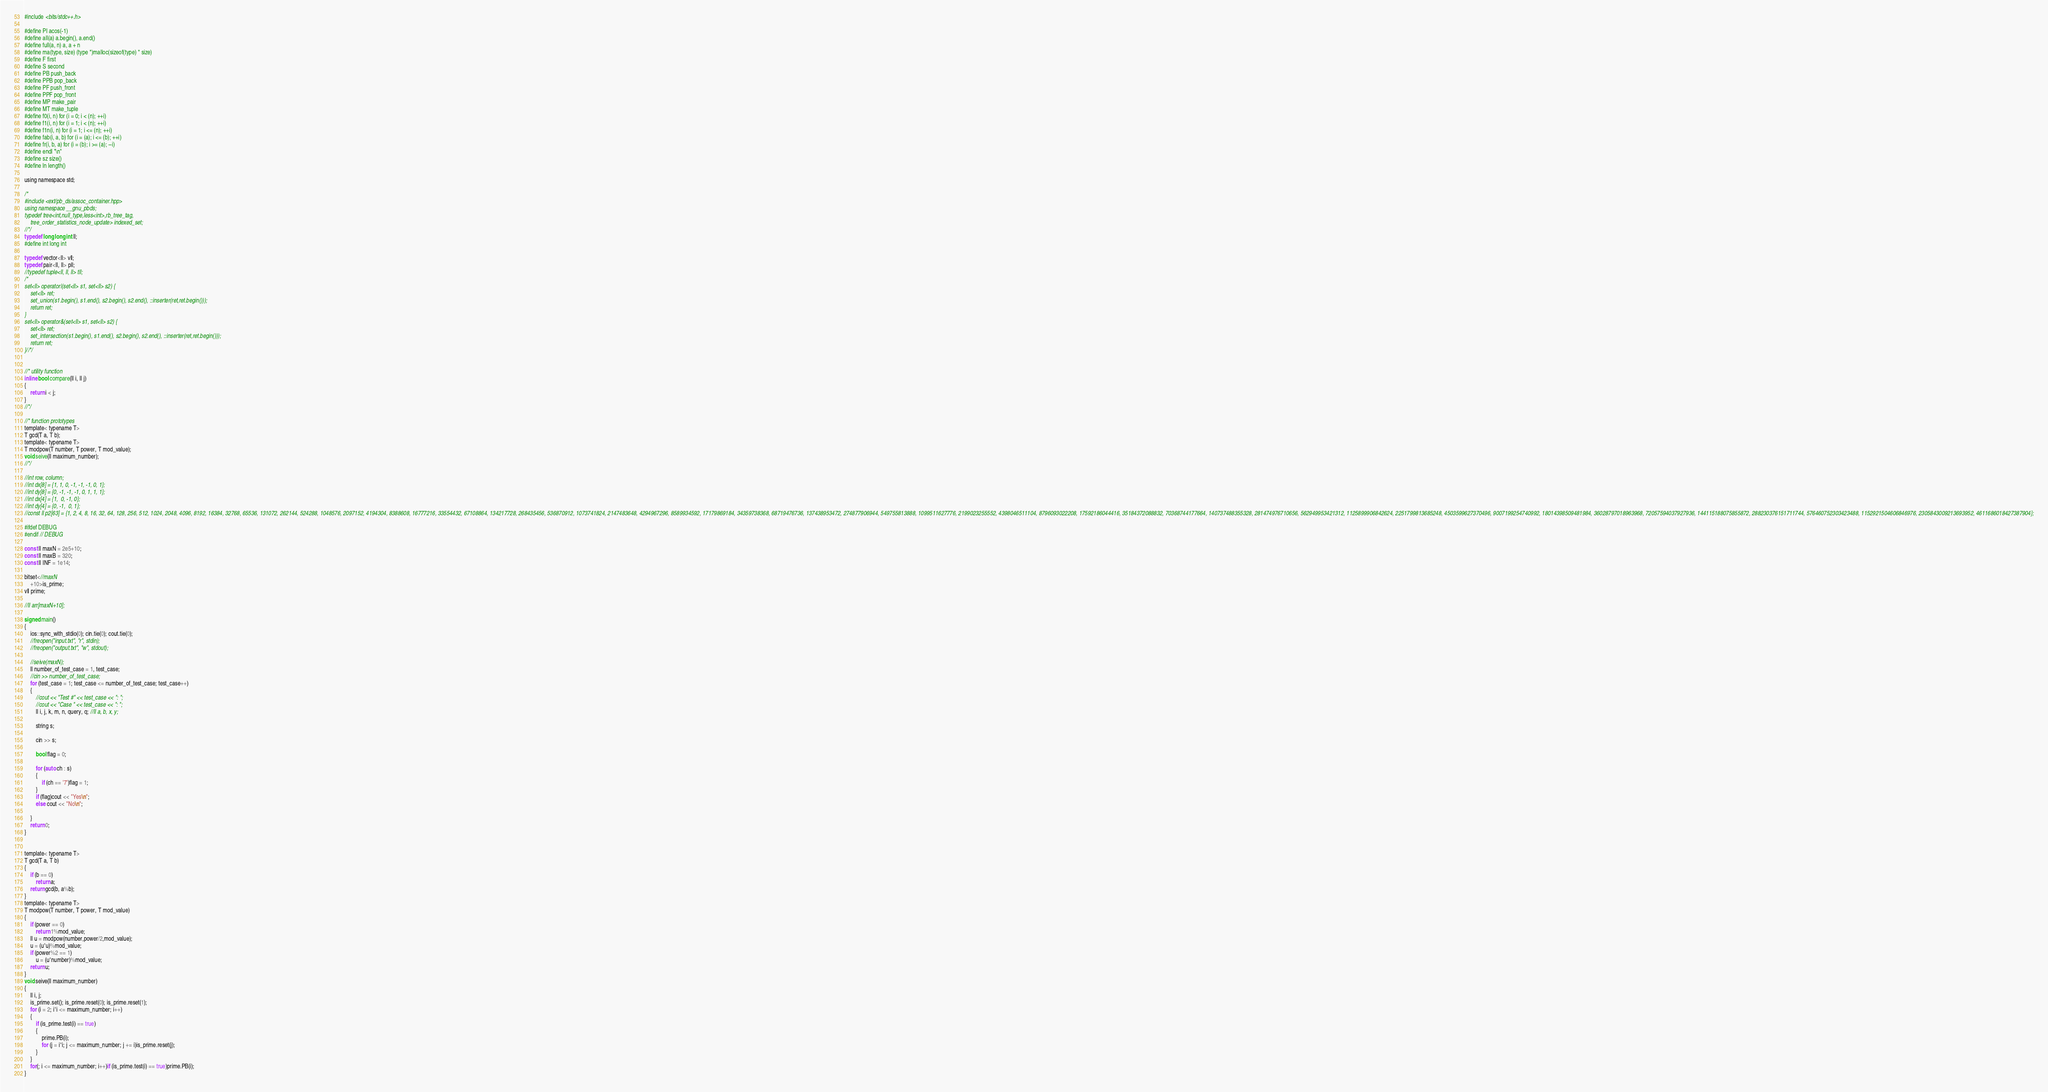Convert code to text. <code><loc_0><loc_0><loc_500><loc_500><_C_>#include <bits/stdc++.h>

#define PI acos(-1)
#define all(a) a.begin(), a.end()
#define full(a, n) a, a + n
#define ma(type, size) (type *)malloc(sizeof(type) * size)
#define F first
#define S second
#define PB push_back
#define PPB pop_back
#define PF push_front
#define PPF pop_front
#define MP make_pair
#define MT make_tuple
#define f0(i, n) for (i = 0; i < (n); ++i)
#define f1(i, n) for (i = 1; i < (n); ++i)
#define f1n(i, n) for (i = 1; i <= (n); ++i)
#define fab(i, a, b) for (i = (a); i <= (b); ++i)
#define fr(i, b, a) for (i = (b); i >= (a); --i)
#define endl "\n"
#define sz size()
#define ln length()

using namespace std;

/*
#include <ext/pb_ds/assoc_container.hpp>
using namespace __gnu_pbds;
typedef tree<int,null_type,less<int>,rb_tree_tag,
	tree_order_statistics_node_update> indexed_set;
//*/
typedef long long int ll;
#define int long int

typedef vector<ll> vll;
typedef pair<ll, ll> pll;
//typedef tuple<ll, ll, ll> tll;
/*
set<ll> operator|(set<ll> s1, set<ll> s2) {
    set<ll> ret;
    set_union(s1.begin(), s1.end(), s2.begin(), s2.end(), ::inserter(ret,ret.begin()));
    return ret;
}
set<ll> operator&(set<ll> s1, set<ll> s2) {
    set<ll> ret;
    set_intersection(s1.begin(), s1.end(), s2.begin(), s2.end(), ::inserter(ret,ret.begin()));
    return ret;
}//*/


//* utility function
inline bool compare(ll i, ll j)
{
    return i < j;
}
//*/

//* function prototypes
template< typename T>
T gcd(T a, T b);
template< typename T>
T modpow(T number, T power, T mod_value);
void seive(ll maximum_number);
//*/

//int row, column;
//int dx[8] = {1, 1, 0, -1, -1, -1, 0, 1};
//int dy[8] = {0, -1, -1, -1, 0, 1, 1, 1};
//int dx[4] = {1,  0, -1, 0};
//int dy[4] = {0, -1,  0, 1};
//const ll p2[63] = {1, 2, 4, 8, 16, 32, 64, 128, 256, 512, 1024, 2048, 4096, 8192, 16384, 32768, 65536, 131072, 262144, 524288, 1048576, 2097152, 4194304, 8388608, 16777216, 33554432, 67108864, 134217728, 268435456, 536870912, 1073741824, 2147483648, 4294967296, 8589934592, 17179869184, 34359738368, 68719476736, 137438953472, 274877906944, 549755813888, 1099511627776, 2199023255552, 4398046511104, 8796093022208, 17592186044416, 35184372088832, 70368744177664, 140737488355328, 281474976710656, 562949953421312, 1125899906842624, 2251799813685248, 4503599627370496, 9007199254740992, 18014398509481984, 36028797018963968, 72057594037927936, 144115188075855872, 288230376151711744, 576460752303423488, 1152921504606846976, 2305843009213693952, 4611686018427387904};

#ifdef DEBUG
#endif // DEBUG

const ll maxN = 2e5+10;
const ll maxB = 320;
const ll INF = 1e14;

bitset<//maxN
    +10>is_prime;
vll prime;

//ll arr[maxN+10];

signed main()
{
    ios::sync_with_stdio(0); cin.tie(0); cout.tie(0);
    //freopen("input.txt", "r", stdin);
    //freopen("output.txt", "w", stdout);

    //seive(maxN);
    ll number_of_test_case = 1, test_case;
    //cin >> number_of_test_case;
    for (test_case = 1; test_case <= number_of_test_case; test_case++)
    {
    	//cout << "Test #" << test_case << ": ";
    	//cout << "Case " << test_case << ": ";
    	ll i, j, k, m, n, query, q; //ll a, b, x, y;

    	string s;

    	cin >> s;

    	bool flag = 0;

    	for (auto ch : s)
        {
            if (ch == '7')flag = 1;
        }
        if (flag)cout << "Yes\n";
        else cout << "No\n";

    }
    return 0;
}


template< typename T>
T gcd(T a, T b)
{
    if (b == 0)
        return a;
    return gcd(b, a%b);
}
template< typename T>
T modpow(T number, T power, T mod_value)
{
    if (power == 0)
        return 1%mod_value;
    ll u = modpow(number,power/2,mod_value);
    u = (u*u)%mod_value;
    if (power%2 == 1)
        u = (u*number)%mod_value;
    return u;
}
void seive(ll maximum_number)
{
    ll i, j;
    is_prime.set(); is_prime.reset(0); is_prime.reset(1);
    for (i = 2; i*i <= maximum_number; i++)
    {
        if (is_prime.test(i) == true)
        {
            prime.PB(i);
            for (j = i*i; j <= maximum_number; j += i)is_prime.reset(j);
        }
    }
    for(; i <= maximum_number; i++)if (is_prime.test(i) == true)prime.PB(i);
}
</code> 